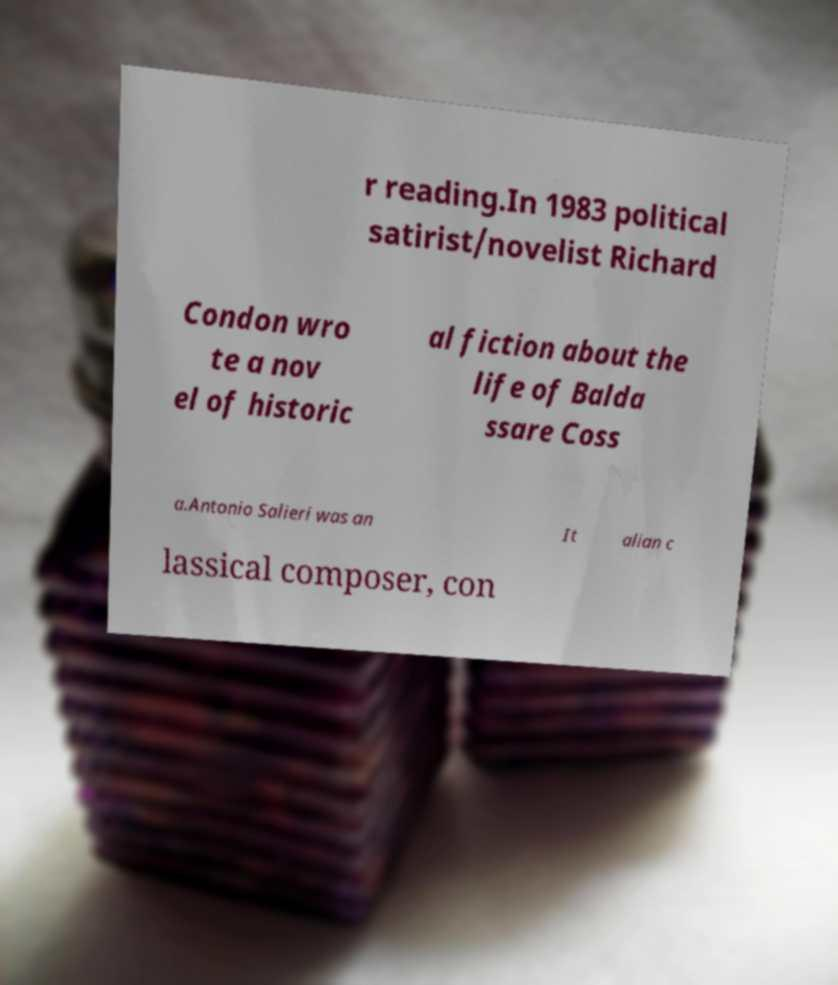There's text embedded in this image that I need extracted. Can you transcribe it verbatim? r reading.In 1983 political satirist/novelist Richard Condon wro te a nov el of historic al fiction about the life of Balda ssare Coss a.Antonio Salieri was an It alian c lassical composer, con 